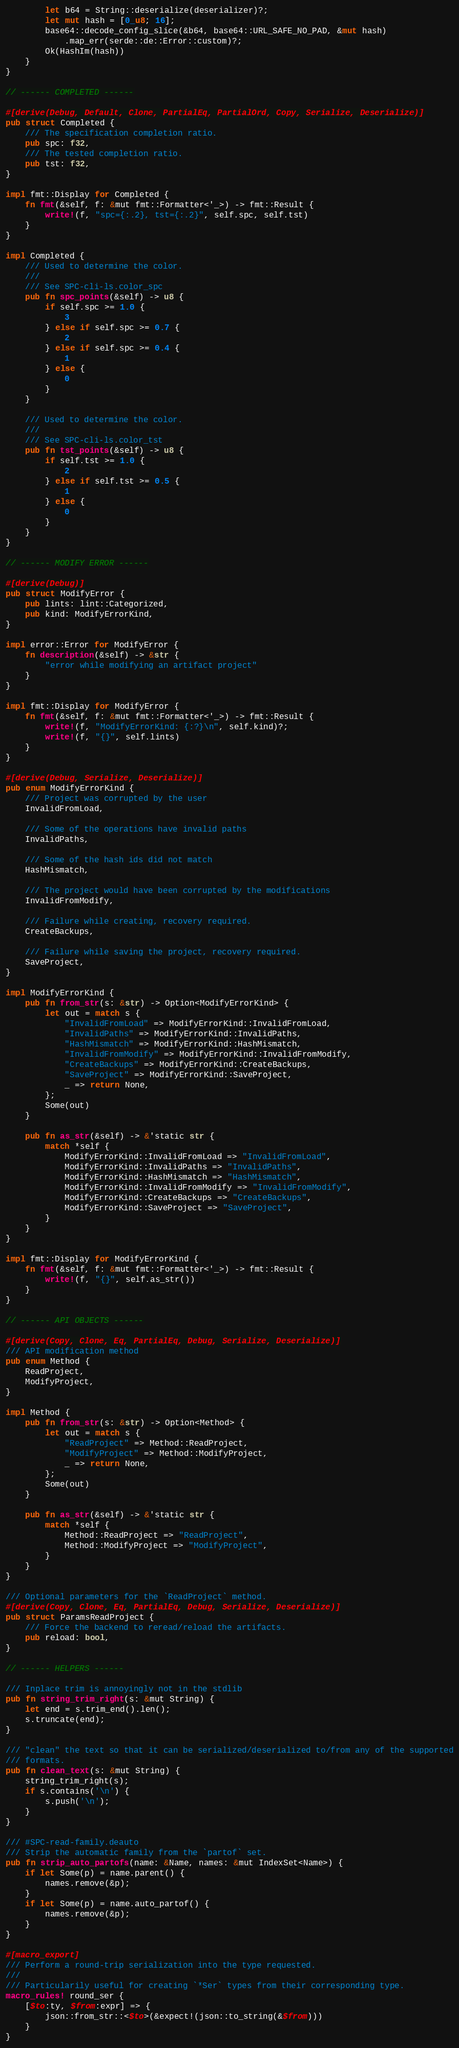<code> <loc_0><loc_0><loc_500><loc_500><_Rust_>        let b64 = String::deserialize(deserializer)?;
        let mut hash = [0_u8; 16];
        base64::decode_config_slice(&b64, base64::URL_SAFE_NO_PAD, &mut hash)
            .map_err(serde::de::Error::custom)?;
        Ok(HashIm(hash))
    }
}

// ------ COMPLETED ------

#[derive(Debug, Default, Clone, PartialEq, PartialOrd, Copy, Serialize, Deserialize)]
pub struct Completed {
    /// The specification completion ratio.
    pub spc: f32,
    /// The tested completion ratio.
    pub tst: f32,
}

impl fmt::Display for Completed {
    fn fmt(&self, f: &mut fmt::Formatter<'_>) -> fmt::Result {
        write!(f, "spc={:.2}, tst={:.2}", self.spc, self.tst)
    }
}

impl Completed {
    /// Used to determine the color.
    ///
    /// See SPC-cli-ls.color_spc
    pub fn spc_points(&self) -> u8 {
        if self.spc >= 1.0 {
            3
        } else if self.spc >= 0.7 {
            2
        } else if self.spc >= 0.4 {
            1
        } else {
            0
        }
    }

    /// Used to determine the color.
    ///
    /// See SPC-cli-ls.color_tst
    pub fn tst_points(&self) -> u8 {
        if self.tst >= 1.0 {
            2
        } else if self.tst >= 0.5 {
            1
        } else {
            0
        }
    }
}

// ------ MODIFY ERROR ------

#[derive(Debug)]
pub struct ModifyError {
    pub lints: lint::Categorized,
    pub kind: ModifyErrorKind,
}

impl error::Error for ModifyError {
    fn description(&self) -> &str {
        "error while modifying an artifact project"
    }
}

impl fmt::Display for ModifyError {
    fn fmt(&self, f: &mut fmt::Formatter<'_>) -> fmt::Result {
        write!(f, "ModifyErrorKind: {:?}\n", self.kind)?;
        write!(f, "{}", self.lints)
    }
}

#[derive(Debug, Serialize, Deserialize)]
pub enum ModifyErrorKind {
    /// Project was corrupted by the user
    InvalidFromLoad,

    /// Some of the operations have invalid paths
    InvalidPaths,

    /// Some of the hash ids did not match
    HashMismatch,

    /// The project would have been corrupted by the modifications
    InvalidFromModify,

    /// Failure while creating, recovery required.
    CreateBackups,

    /// Failure while saving the project, recovery required.
    SaveProject,
}

impl ModifyErrorKind {
    pub fn from_str(s: &str) -> Option<ModifyErrorKind> {
        let out = match s {
            "InvalidFromLoad" => ModifyErrorKind::InvalidFromLoad,
            "InvalidPaths" => ModifyErrorKind::InvalidPaths,
            "HashMismatch" => ModifyErrorKind::HashMismatch,
            "InvalidFromModify" => ModifyErrorKind::InvalidFromModify,
            "CreateBackups" => ModifyErrorKind::CreateBackups,
            "SaveProject" => ModifyErrorKind::SaveProject,
            _ => return None,
        };
        Some(out)
    }

    pub fn as_str(&self) -> &'static str {
        match *self {
            ModifyErrorKind::InvalidFromLoad => "InvalidFromLoad",
            ModifyErrorKind::InvalidPaths => "InvalidPaths",
            ModifyErrorKind::HashMismatch => "HashMismatch",
            ModifyErrorKind::InvalidFromModify => "InvalidFromModify",
            ModifyErrorKind::CreateBackups => "CreateBackups",
            ModifyErrorKind::SaveProject => "SaveProject",
        }
    }
}

impl fmt::Display for ModifyErrorKind {
    fn fmt(&self, f: &mut fmt::Formatter<'_>) -> fmt::Result {
        write!(f, "{}", self.as_str())
    }
}

// ------ API OBJECTS ------

#[derive(Copy, Clone, Eq, PartialEq, Debug, Serialize, Deserialize)]
/// API modification method
pub enum Method {
    ReadProject,
    ModifyProject,
}

impl Method {
    pub fn from_str(s: &str) -> Option<Method> {
        let out = match s {
            "ReadProject" => Method::ReadProject,
            "ModifyProject" => Method::ModifyProject,
            _ => return None,
        };
        Some(out)
    }

    pub fn as_str(&self) -> &'static str {
        match *self {
            Method::ReadProject => "ReadProject",
            Method::ModifyProject => "ModifyProject",
        }
    }
}

/// Optional parameters for the `ReadProject` method.
#[derive(Copy, Clone, Eq, PartialEq, Debug, Serialize, Deserialize)]
pub struct ParamsReadProject {
    /// Force the backend to reread/reload the artifacts.
    pub reload: bool,
}

// ------ HELPERS ------

/// Inplace trim is annoyingly not in the stdlib
pub fn string_trim_right(s: &mut String) {
    let end = s.trim_end().len();
    s.truncate(end);
}

/// "clean" the text so that it can be serialized/deserialized to/from any of the supported
/// formats.
pub fn clean_text(s: &mut String) {
    string_trim_right(s);
    if s.contains('\n') {
        s.push('\n');
    }
}

/// #SPC-read-family.deauto
/// Strip the automatic family from the `partof` set.
pub fn strip_auto_partofs(name: &Name, names: &mut IndexSet<Name>) {
    if let Some(p) = name.parent() {
        names.remove(&p);
    }
    if let Some(p) = name.auto_partof() {
        names.remove(&p);
    }
}

#[macro_export]
/// Perform a round-trip serialization into the type requested.
///
/// Particularily useful for creating `*Ser` types from their corresponding type.
macro_rules! round_ser {
    [$to:ty, $from:expr] => {
        json::from_str::<$to>(&expect!(json::to_string(&$from)))
    }
}
</code> 